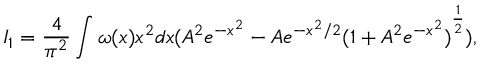<formula> <loc_0><loc_0><loc_500><loc_500>I _ { 1 } = { \frac { 4 } { \pi ^ { 2 } } } \int { \omega ( x ) x ^ { 2 } d x ( A ^ { 2 } e ^ { - x ^ { 2 } } - A e ^ { - { { x ^ { 2 } } / 2 } } { ( 1 + A ^ { 2 } e ^ { - x ^ { 2 } } ) } ^ { \frac { 1 } { 2 } } ) } ,</formula> 